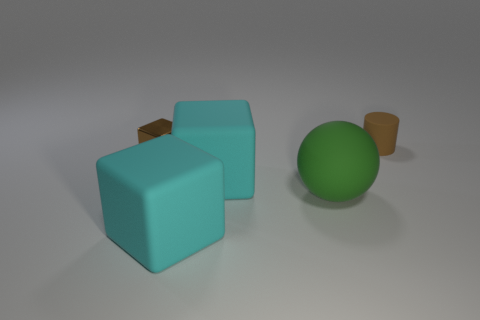Subtract all large rubber blocks. How many blocks are left? 1 Subtract all brown blocks. How many blocks are left? 2 Subtract all cylinders. How many objects are left? 4 Subtract all cyan cubes. How many yellow balls are left? 0 Add 4 tiny metal cubes. How many tiny metal cubes are left? 5 Add 5 red matte cubes. How many red matte cubes exist? 5 Add 1 tiny things. How many objects exist? 6 Subtract 0 gray blocks. How many objects are left? 5 Subtract all gray cylinders. Subtract all green cubes. How many cylinders are left? 1 Subtract all small purple metallic cylinders. Subtract all big green spheres. How many objects are left? 4 